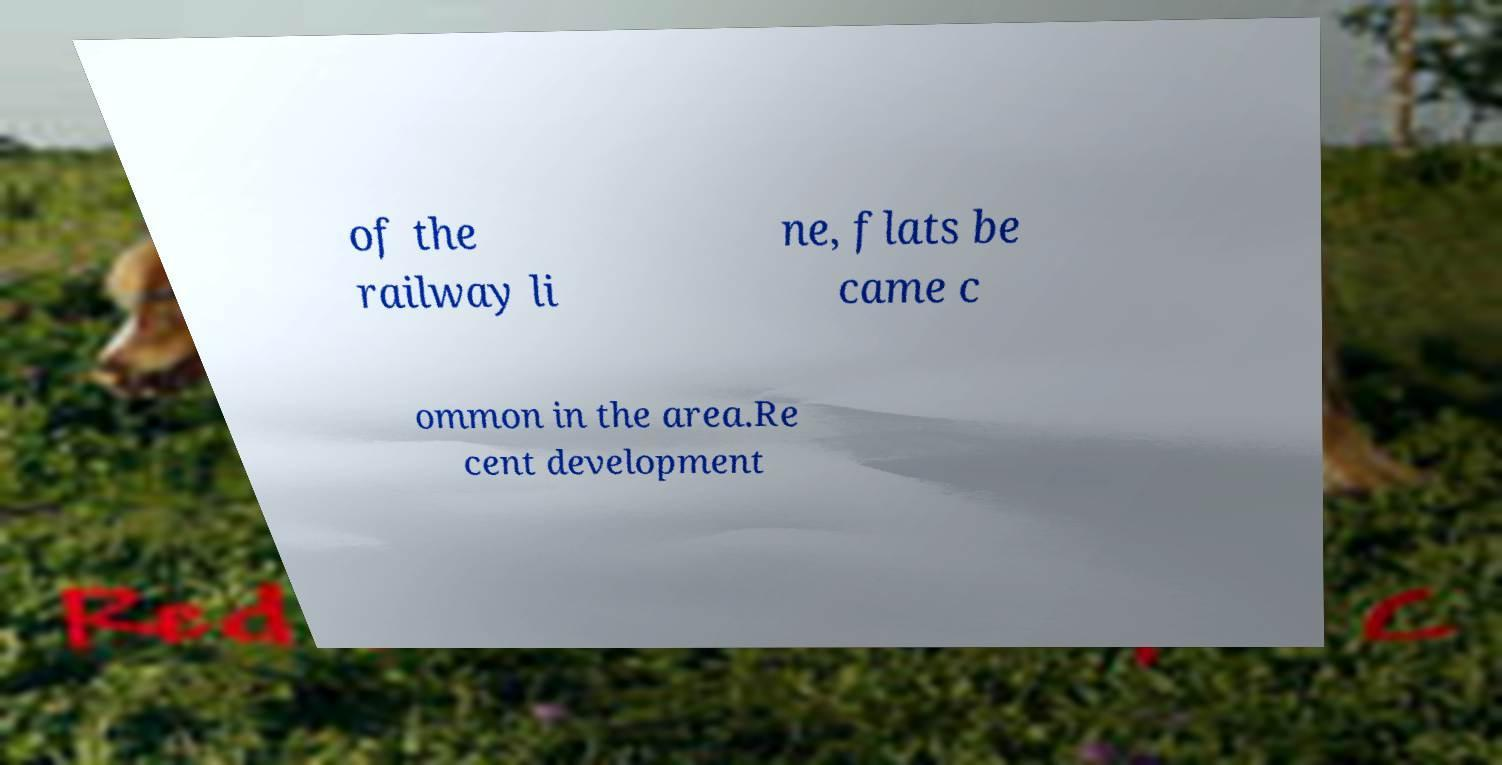For documentation purposes, I need the text within this image transcribed. Could you provide that? of the railway li ne, flats be came c ommon in the area.Re cent development 